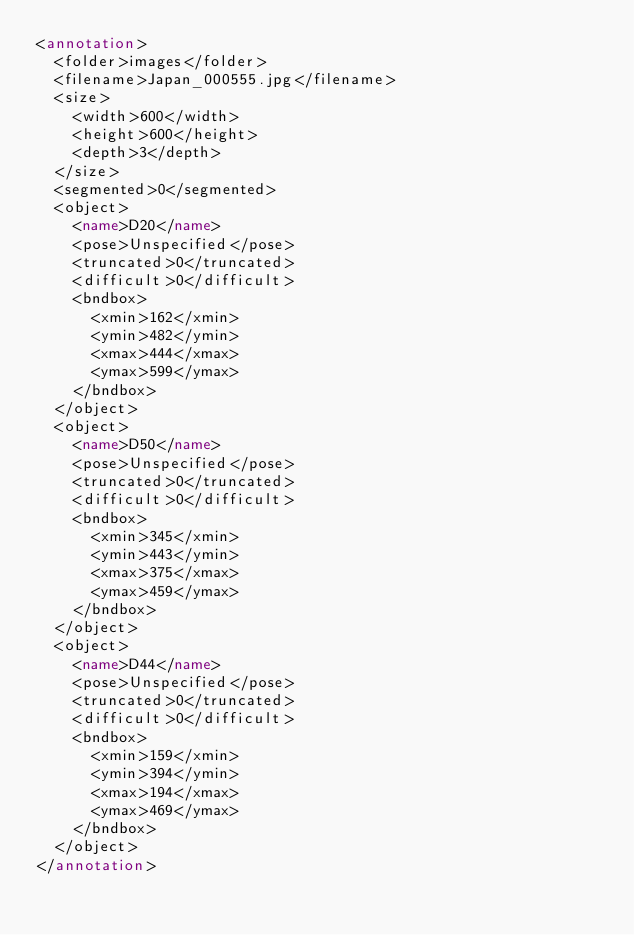Convert code to text. <code><loc_0><loc_0><loc_500><loc_500><_XML_><annotation>
	<folder>images</folder>
	<filename>Japan_000555.jpg</filename>
	<size>
		<width>600</width>
		<height>600</height>
		<depth>3</depth>
	</size>
	<segmented>0</segmented>
	<object>
		<name>D20</name>
		<pose>Unspecified</pose>
		<truncated>0</truncated>
		<difficult>0</difficult>
		<bndbox>
			<xmin>162</xmin>
			<ymin>482</ymin>
			<xmax>444</xmax>
			<ymax>599</ymax>
		</bndbox>
	</object>
	<object>
		<name>D50</name>
		<pose>Unspecified</pose>
		<truncated>0</truncated>
		<difficult>0</difficult>
		<bndbox>
			<xmin>345</xmin>
			<ymin>443</ymin>
			<xmax>375</xmax>
			<ymax>459</ymax>
		</bndbox>
	</object>
	<object>
		<name>D44</name>
		<pose>Unspecified</pose>
		<truncated>0</truncated>
		<difficult>0</difficult>
		<bndbox>
			<xmin>159</xmin>
			<ymin>394</ymin>
			<xmax>194</xmax>
			<ymax>469</ymax>
		</bndbox>
	</object>
</annotation></code> 